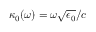<formula> <loc_0><loc_0><loc_500><loc_500>\kappa _ { 0 } ( \omega ) = \omega \sqrt { \epsilon _ { 0 } } / c</formula> 